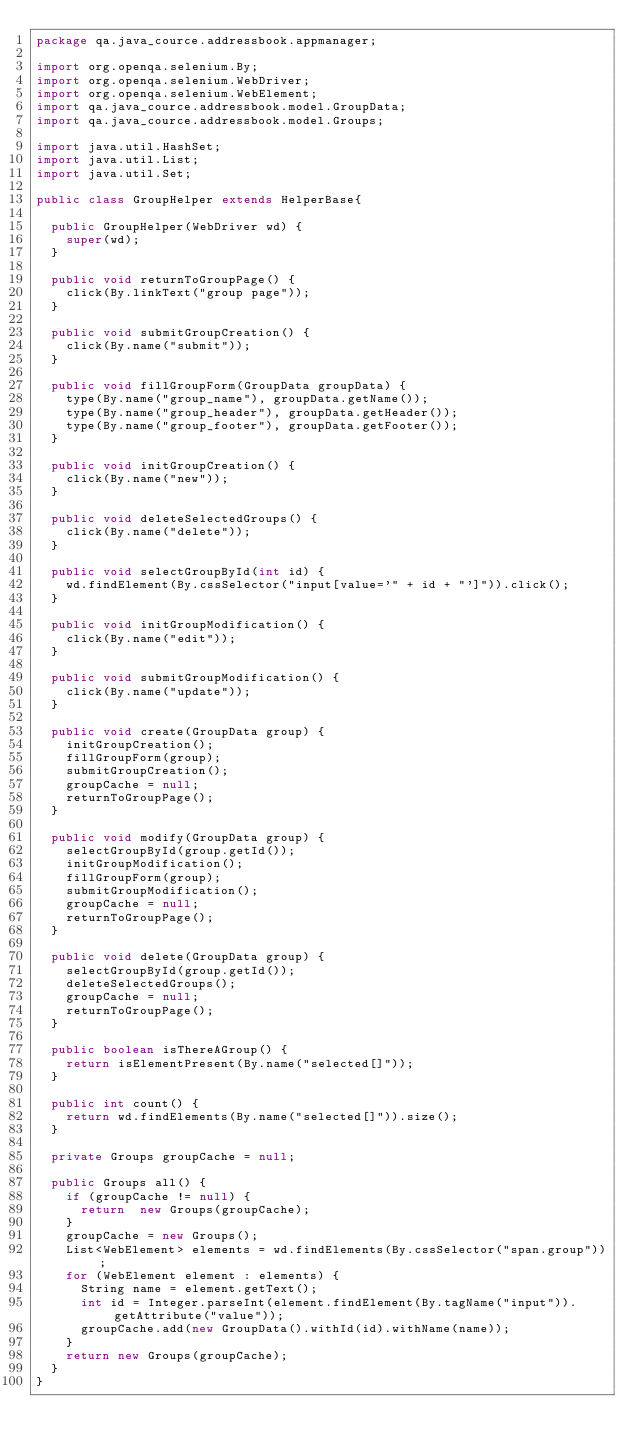Convert code to text. <code><loc_0><loc_0><loc_500><loc_500><_Java_>package qa.java_cource.addressbook.appmanager;

import org.openqa.selenium.By;
import org.openqa.selenium.WebDriver;
import org.openqa.selenium.WebElement;
import qa.java_cource.addressbook.model.GroupData;
import qa.java_cource.addressbook.model.Groups;

import java.util.HashSet;
import java.util.List;
import java.util.Set;

public class GroupHelper extends HelperBase{

  public GroupHelper(WebDriver wd) {
    super(wd);
  }

  public void returnToGroupPage() {
    click(By.linkText("group page"));
  }

  public void submitGroupCreation() {
    click(By.name("submit"));
  }

  public void fillGroupForm(GroupData groupData) {
    type(By.name("group_name"), groupData.getName());
    type(By.name("group_header"), groupData.getHeader());
    type(By.name("group_footer"), groupData.getFooter());
  }

  public void initGroupCreation() {
    click(By.name("new"));
  }

  public void deleteSelectedGroups() {
    click(By.name("delete"));
  }

  public void selectGroupById(int id) {
    wd.findElement(By.cssSelector("input[value='" + id + "']")).click();
  }

  public void initGroupModification() {
    click(By.name("edit"));
  }

  public void submitGroupModification() {
    click(By.name("update"));
  }

  public void create(GroupData group) {
    initGroupCreation();
    fillGroupForm(group);
    submitGroupCreation();
    groupCache = null;
    returnToGroupPage();
  }

  public void modify(GroupData group) {
    selectGroupById(group.getId());
    initGroupModification();
    fillGroupForm(group);
    submitGroupModification();
    groupCache = null;
    returnToGroupPage();
  }

  public void delete(GroupData group) {
    selectGroupById(group.getId());
    deleteSelectedGroups();
    groupCache = null;
    returnToGroupPage();
  }

  public boolean isThereAGroup() {
    return isElementPresent(By.name("selected[]"));
  }

  public int count() {
    return wd.findElements(By.name("selected[]")).size();
  }

  private Groups groupCache = null;

  public Groups all() {
    if (groupCache != null) {
      return  new Groups(groupCache);
    }
    groupCache = new Groups();
    List<WebElement> elements = wd.findElements(By.cssSelector("span.group"));
    for (WebElement element : elements) {
      String name = element.getText();
      int id = Integer.parseInt(element.findElement(By.tagName("input")).getAttribute("value"));
      groupCache.add(new GroupData().withId(id).withName(name));
    }
    return new Groups(groupCache);
  }
}
</code> 